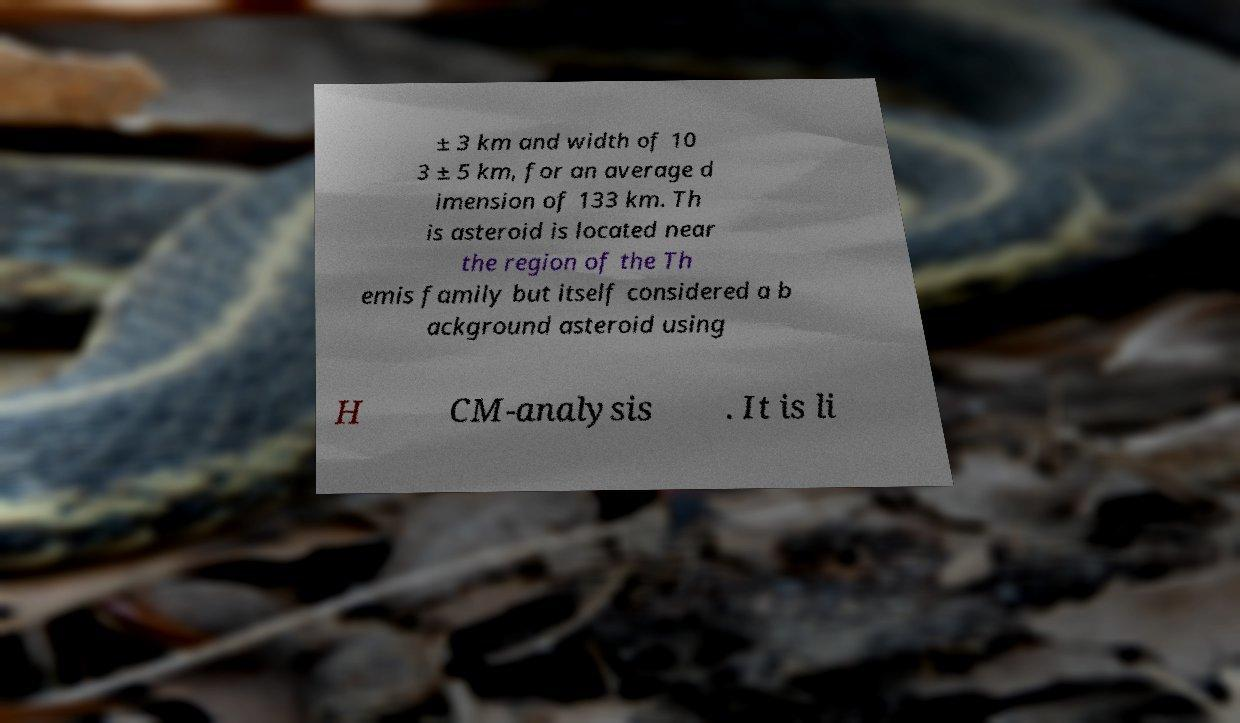Can you accurately transcribe the text from the provided image for me? ± 3 km and width of 10 3 ± 5 km, for an average d imension of 133 km. Th is asteroid is located near the region of the Th emis family but itself considered a b ackground asteroid using H CM-analysis . It is li 